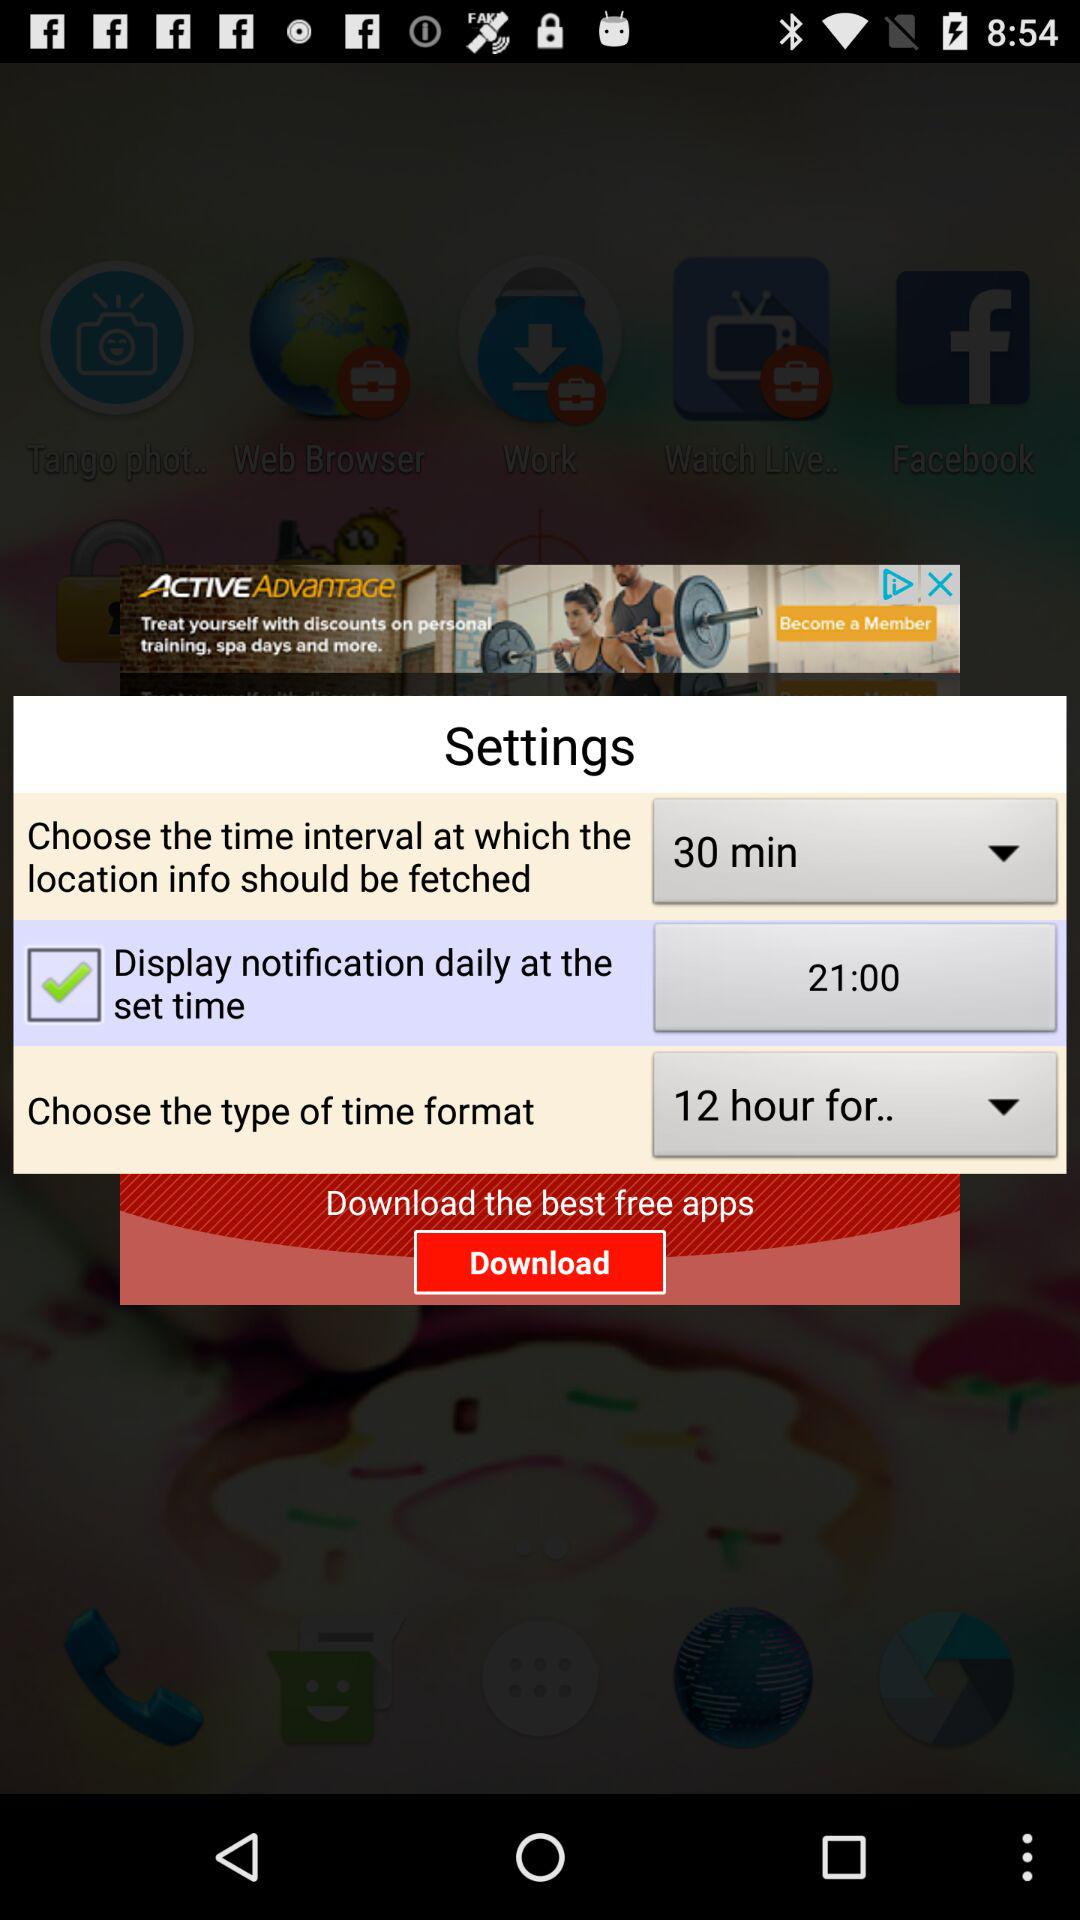Which option is selected for the time format? The selected option is "12 hour for..". 